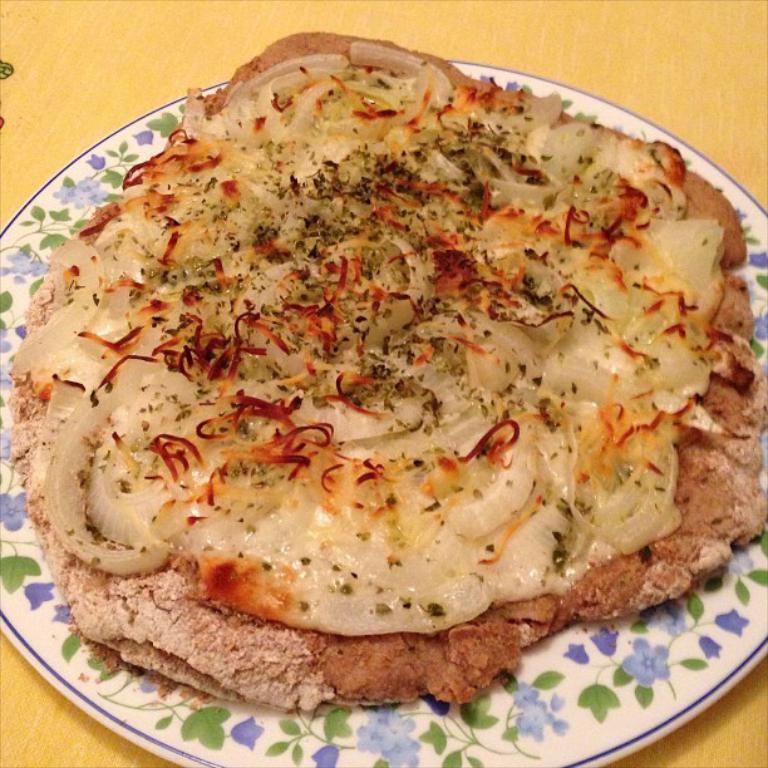Describe this image in one or two sentences. In this image there is a table and we can see a plate containing food placed on the table. 